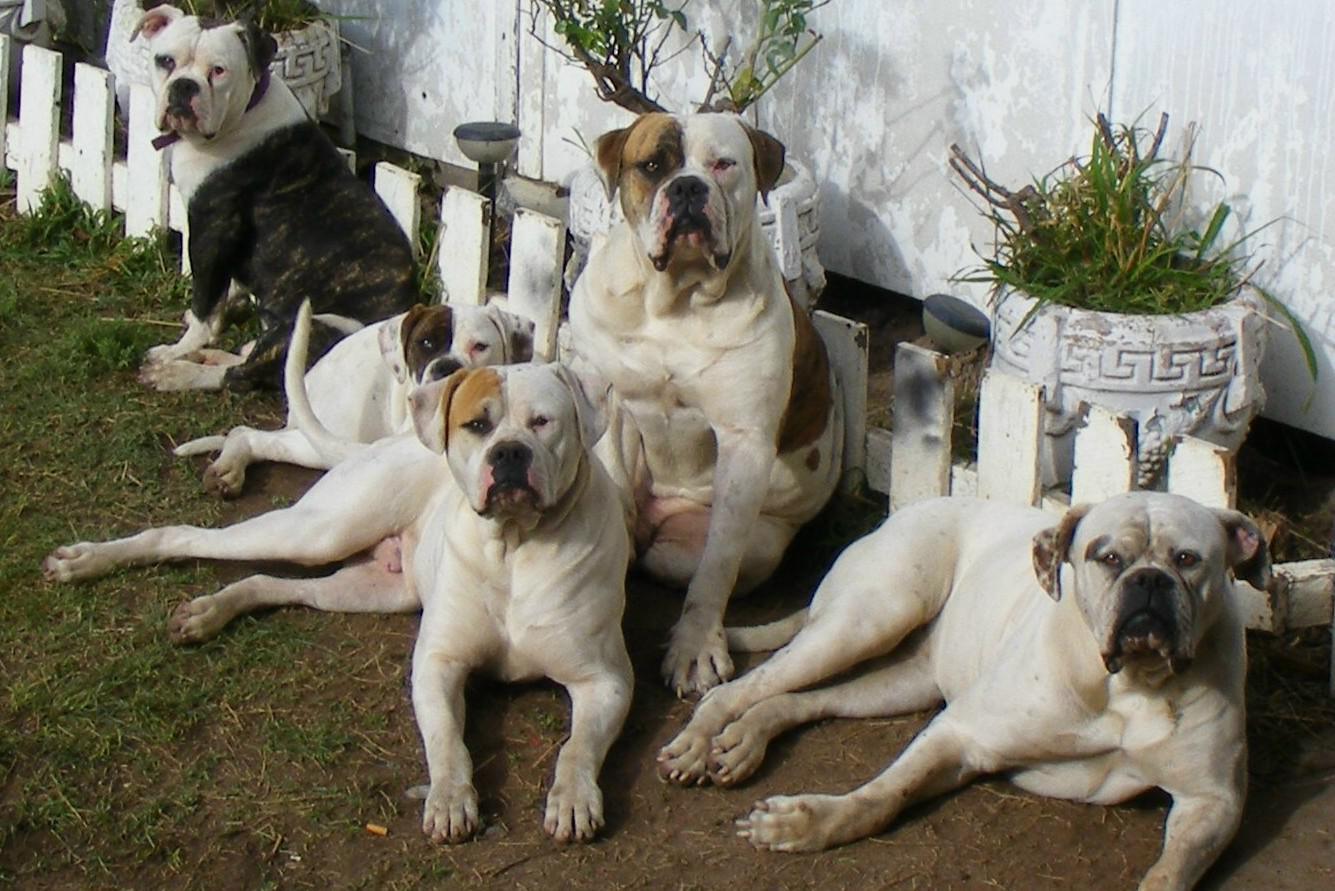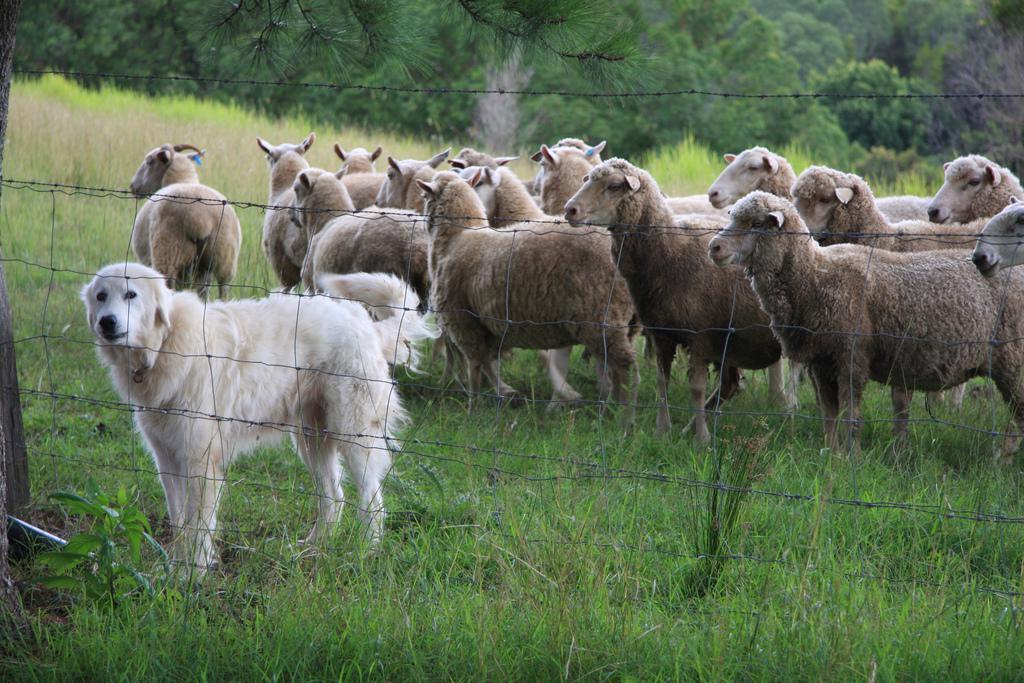The first image is the image on the left, the second image is the image on the right. For the images displayed, is the sentence "There is a dog standing next to a fence." factually correct? Answer yes or no. Yes. 